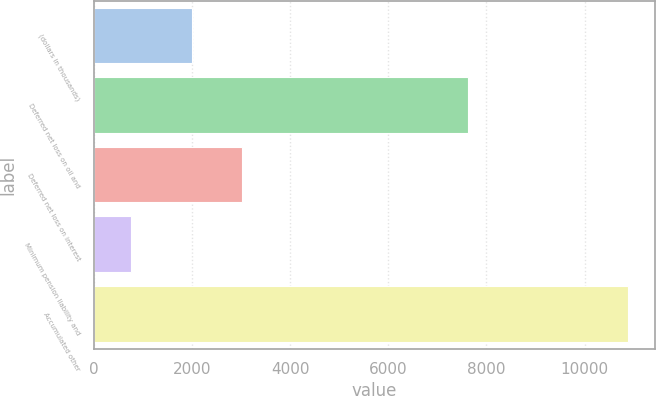Convert chart. <chart><loc_0><loc_0><loc_500><loc_500><bar_chart><fcel>(dollars in thousands)<fcel>Deferred net loss on oil and<fcel>Deferred net loss on interest<fcel>Minimum pension liability and<fcel>Accumulated other<nl><fcel>2003<fcel>7618<fcel>3015.7<fcel>759<fcel>10886<nl></chart> 